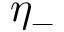<formula> <loc_0><loc_0><loc_500><loc_500>\eta _ { - }</formula> 